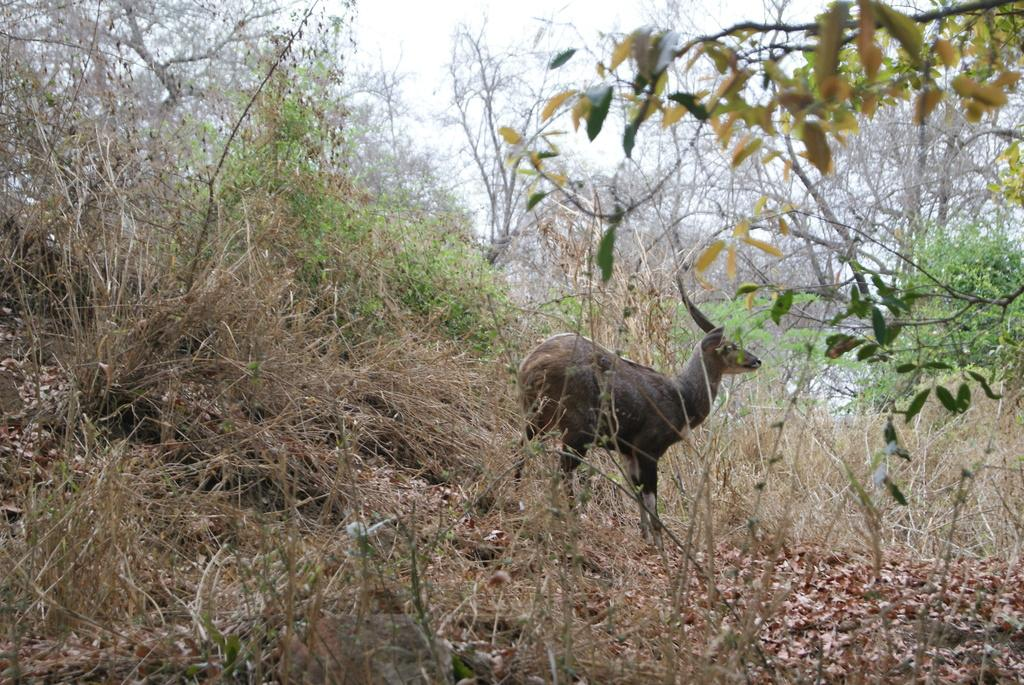What type of animal is in the image? The type of animal cannot be determined from the provided facts. What can be seen in the background of the image? In the background of the image, there are trees, twigs, dry leaves, plants, and the sky. Are there any other objects visible in the background of the image? Yes, there are other objects in the background of the image. What type of pie is being served on the desk in the office in the image? There is no desk, pie, or office present in the image. 